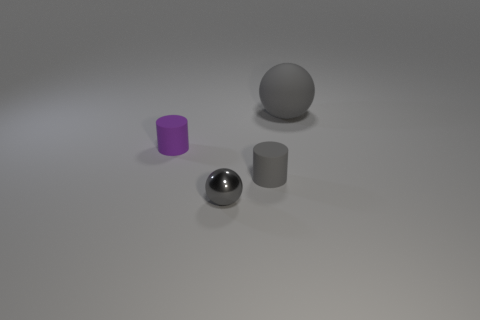Are there any other things that are made of the same material as the small gray ball?
Your answer should be compact. No. Is the shape of the big thing the same as the small purple matte thing?
Your answer should be very brief. No. There is a matte thing that is on the right side of the small gray metal thing and left of the large thing; what is its color?
Give a very brief answer. Gray. There is a gray rubber thing on the left side of the big gray matte ball; is it the same size as the gray sphere in front of the purple rubber cylinder?
Make the answer very short. Yes. What number of things are either rubber things on the left side of the big matte sphere or large matte things?
Your answer should be compact. 3. What is the material of the small purple thing?
Offer a terse response. Rubber. Does the purple thing have the same size as the gray matte sphere?
Give a very brief answer. No. What number of cubes are either big gray objects or green shiny objects?
Provide a succinct answer. 0. What is the color of the tiny metal object that is to the right of the tiny matte thing on the left side of the gray metal ball?
Keep it short and to the point. Gray. Is the number of big gray rubber spheres in front of the small purple cylinder less than the number of purple cylinders to the left of the tiny metal thing?
Give a very brief answer. Yes. 